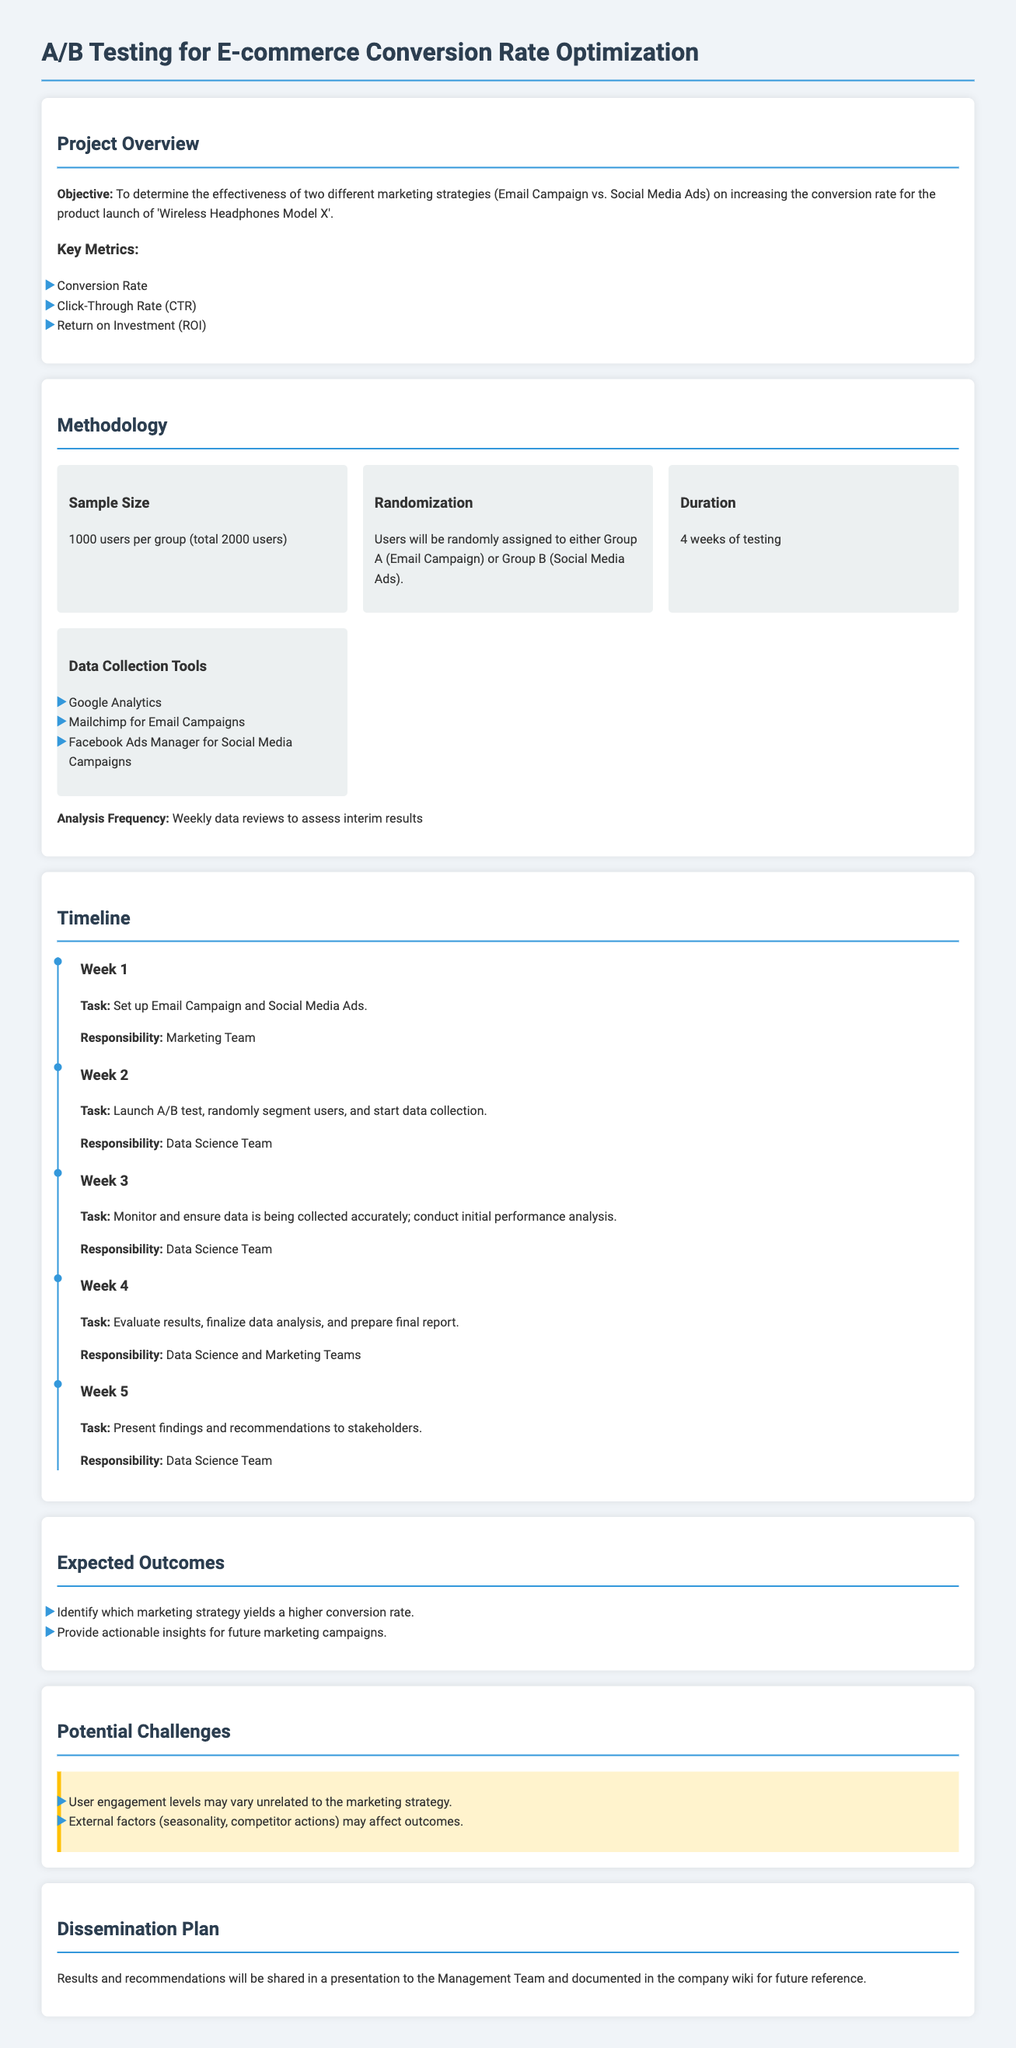What is the objective of the A/B testing? The objective is to determine the effectiveness of two different marketing strategies on increasing the conversion rate for the product launch.
Answer: To determine the effectiveness of two different marketing strategies What is the sample size for each group? The sample size for each group is mentioned in the sample size section of the methodology.
Answer: 1000 users per group How long will the A/B test run? The duration of the test is specifically stated in the methodology section.
Answer: 4 weeks Which team is responsible for launching the A/B test? The responsibility for launching the A/B test is outlined in the timeline section.
Answer: Data Science Team What tools will be used for data collection? The tools for data collection are listed in the methodology section.
Answer: Google Analytics, Mailchimp, Facebook Ads Manager What is one potential challenge of the A/B testing? The document lists potential challenges related to user engagement levels and external factors.
Answer: User engagement levels may vary What will be shared in the presentation to stakeholders? The key content to be shared in the presentation is described in the dissemination plan section.
Answer: Findings and recommendations What is the main focus of the expected outcomes? The expected outcomes detail the goals of the A/B testing results.
Answer: Identify which marketing strategy yields a higher conversion rate In which week will the initial performance analysis be conducted? The timeline specifies in which week the initial performance analysis is scheduled.
Answer: Week 3 How will the results be documented for future reference? The plan for documentation of results is outlined in the dissemination plan.
Answer: In the company wiki 